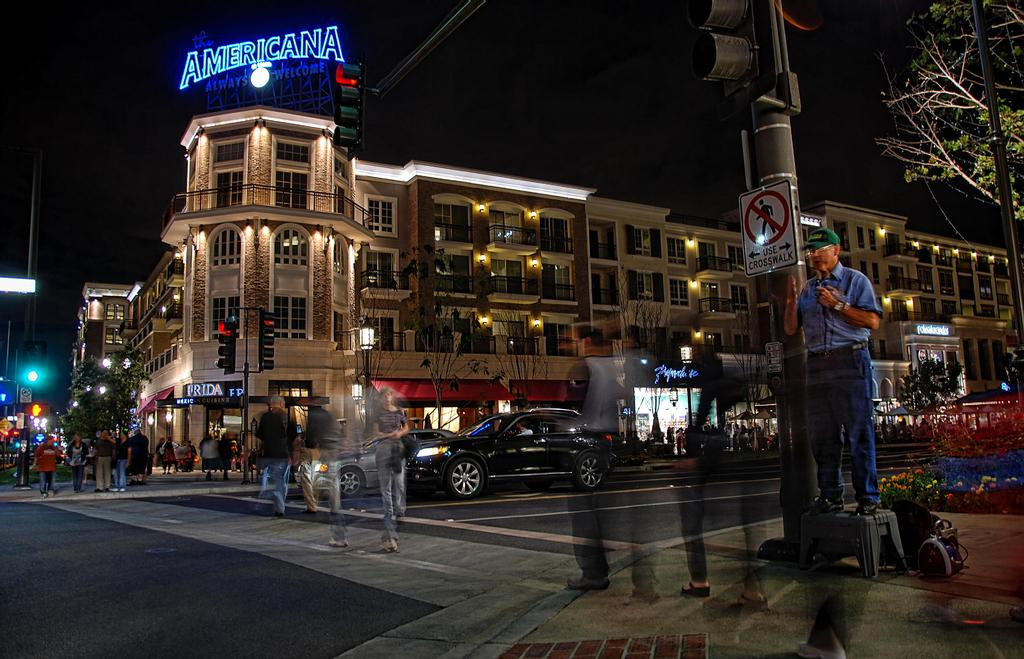What is happening in the image? There is a group of people standing in the image. What else can be seen in the image besides the people? There are vehicles on the road, buildings, poles, lights, boards, and trees in the image. Can you describe the lighting in the image? There are lights in the image. What is the color of the background in the image? The background of the image is dark. Where are the mice hiding in the image? There are no mice present in the image. What advice would the dad in the image give to his children? There is no dad present in the image, so it is not possible to determine what advice he might give. 